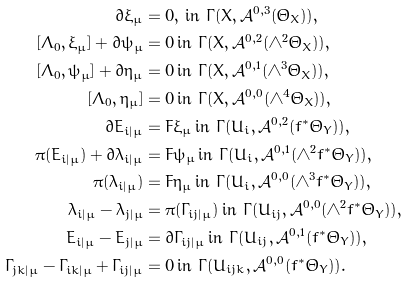<formula> <loc_0><loc_0><loc_500><loc_500>\bar { \partial } \xi _ { \mu } & = 0 , \, \text {in $\Gamma(X, \mathcal{A}^{0,3}(\Theta_{X}))$} , \\ [ \Lambda _ { 0 } , \xi _ { \mu } ] + \bar { \partial } \psi _ { \mu } & = 0 \, \text {in $\Gamma(X, \mathcal{A}^{0,2}(\wedge^{2}\Theta_{X}))$} , \\ [ \Lambda _ { 0 } , \psi _ { \mu } ] + \bar { \partial } \eta _ { \mu } & = 0 \, \text {in $\Gamma(X, \mathcal{A}^{0,1}(\wedge^{3}\Theta_{X}))$} , \\ [ \Lambda _ { 0 } , \eta _ { \mu } ] & = 0 \, \text {in $\Gamma(X, \mathcal{A}^{0,0}(\wedge^{4}\Theta_{X}))$} , \\ \bar { \partial } E _ { i | \mu } & = F \xi _ { \mu } \, \text {in $\Gamma(U_{i}, \mathcal{A}^{0,2}(f^{*}\Theta_{Y}))$} , \\ \pi ( E _ { i | \mu } ) + \bar { \partial } \lambda _ { i | \mu } & = F \psi _ { \mu } \, \text {in $\Gamma(U_{i}, \mathcal{A}^{0,1}(\wedge^{2} f^{*}\Theta_{Y}))$} , \\ \pi ( \lambda _ { i | \mu } ) & = F \eta _ { \mu } \, \text {in $\Gamma(U_{i}, \mathcal{A}^{0,0}(\wedge^{3} f^{*}\Theta_{Y}))$} , \\ \lambda _ { i | \mu } - \lambda _ { j | \mu } & = \pi ( \Gamma _ { i j | \mu } ) \, \text {in $\Gamma(U_{ij},\mathcal{A}^{0,0}(\wedge^{2} f^{*}\Theta_{Y}))$} , \\ E _ { i | \mu } - E _ { j | \mu } & = \bar { \partial } \Gamma _ { i j | \mu } \, \text {in $\Gamma(U_{ij},\mathcal{A}^{0,1}(f^{*}\Theta_{Y}))$} , \\ \Gamma _ { j k | \mu } - \Gamma _ { i k | \mu } + \Gamma _ { i j | \mu } & = 0 \, \text {in $\Gamma(U_{ijk},\mathcal{A}^{0,0}(f^{*}\Theta_{Y}))$} .</formula> 